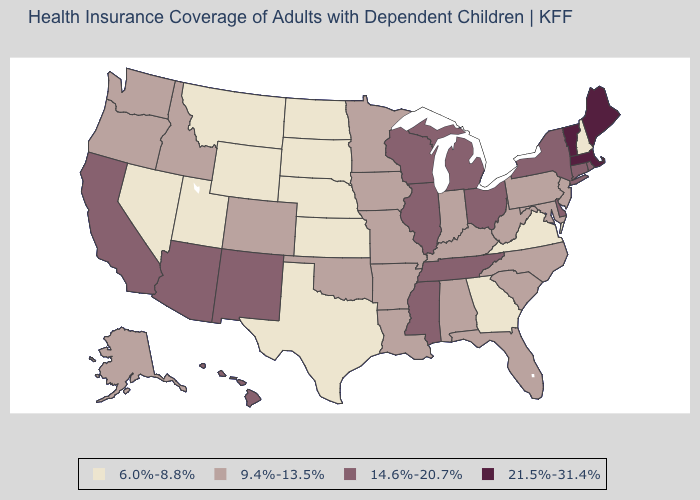Name the states that have a value in the range 21.5%-31.4%?
Be succinct. Maine, Massachusetts, Vermont. What is the value of Texas?
Be succinct. 6.0%-8.8%. Which states have the lowest value in the West?
Be succinct. Montana, Nevada, Utah, Wyoming. What is the value of Michigan?
Concise answer only. 14.6%-20.7%. Does Mississippi have the highest value in the South?
Write a very short answer. Yes. Does New Mexico have a higher value than Pennsylvania?
Keep it brief. Yes. What is the value of Kansas?
Quick response, please. 6.0%-8.8%. Is the legend a continuous bar?
Quick response, please. No. What is the lowest value in the USA?
Short answer required. 6.0%-8.8%. Among the states that border New Mexico , does Colorado have the highest value?
Give a very brief answer. No. What is the value of Utah?
Keep it brief. 6.0%-8.8%. Does Michigan have a lower value than Maine?
Answer briefly. Yes. Among the states that border Indiana , does Ohio have the highest value?
Quick response, please. Yes. Which states have the highest value in the USA?
Keep it brief. Maine, Massachusetts, Vermont. Name the states that have a value in the range 14.6%-20.7%?
Give a very brief answer. Arizona, California, Connecticut, Delaware, Hawaii, Illinois, Michigan, Mississippi, New Mexico, New York, Ohio, Rhode Island, Tennessee, Wisconsin. 